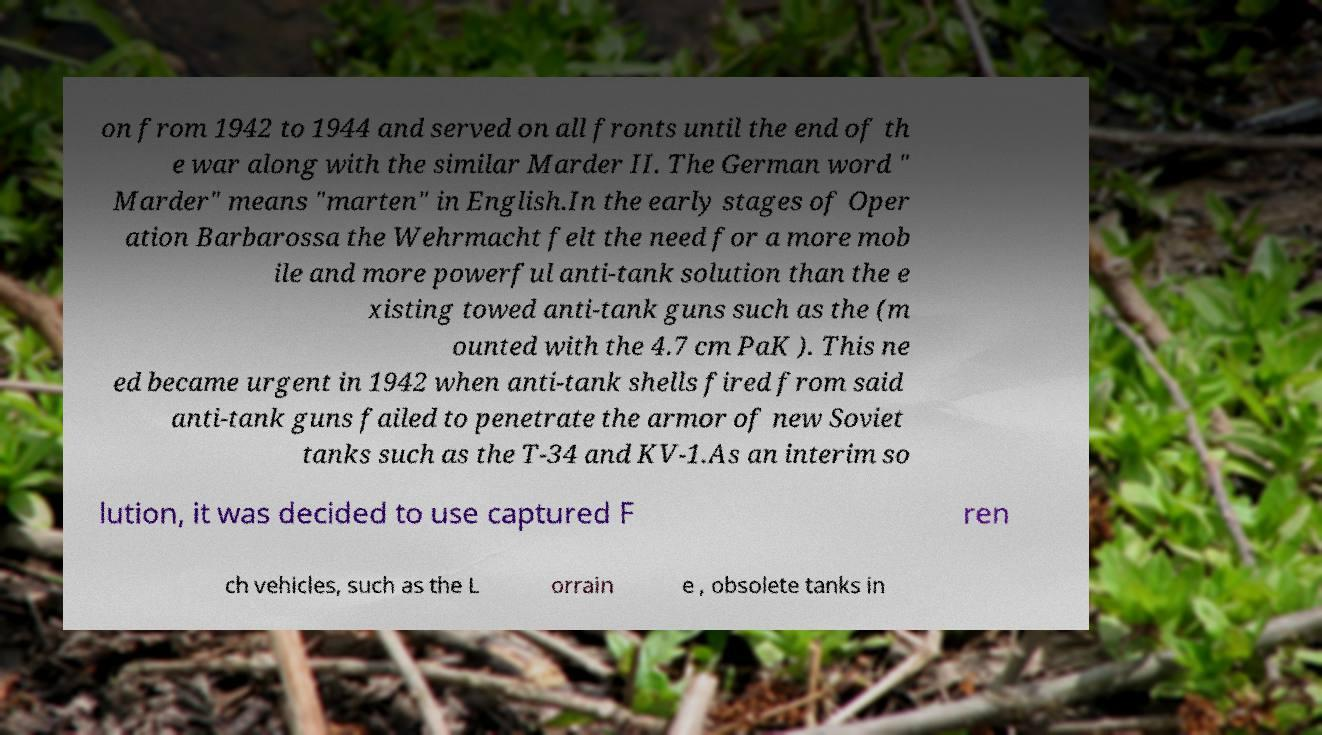Can you read and provide the text displayed in the image?This photo seems to have some interesting text. Can you extract and type it out for me? on from 1942 to 1944 and served on all fronts until the end of th e war along with the similar Marder II. The German word " Marder" means "marten" in English.In the early stages of Oper ation Barbarossa the Wehrmacht felt the need for a more mob ile and more powerful anti-tank solution than the e xisting towed anti-tank guns such as the (m ounted with the 4.7 cm PaK ). This ne ed became urgent in 1942 when anti-tank shells fired from said anti-tank guns failed to penetrate the armor of new Soviet tanks such as the T-34 and KV-1.As an interim so lution, it was decided to use captured F ren ch vehicles, such as the L orrain e , obsolete tanks in 